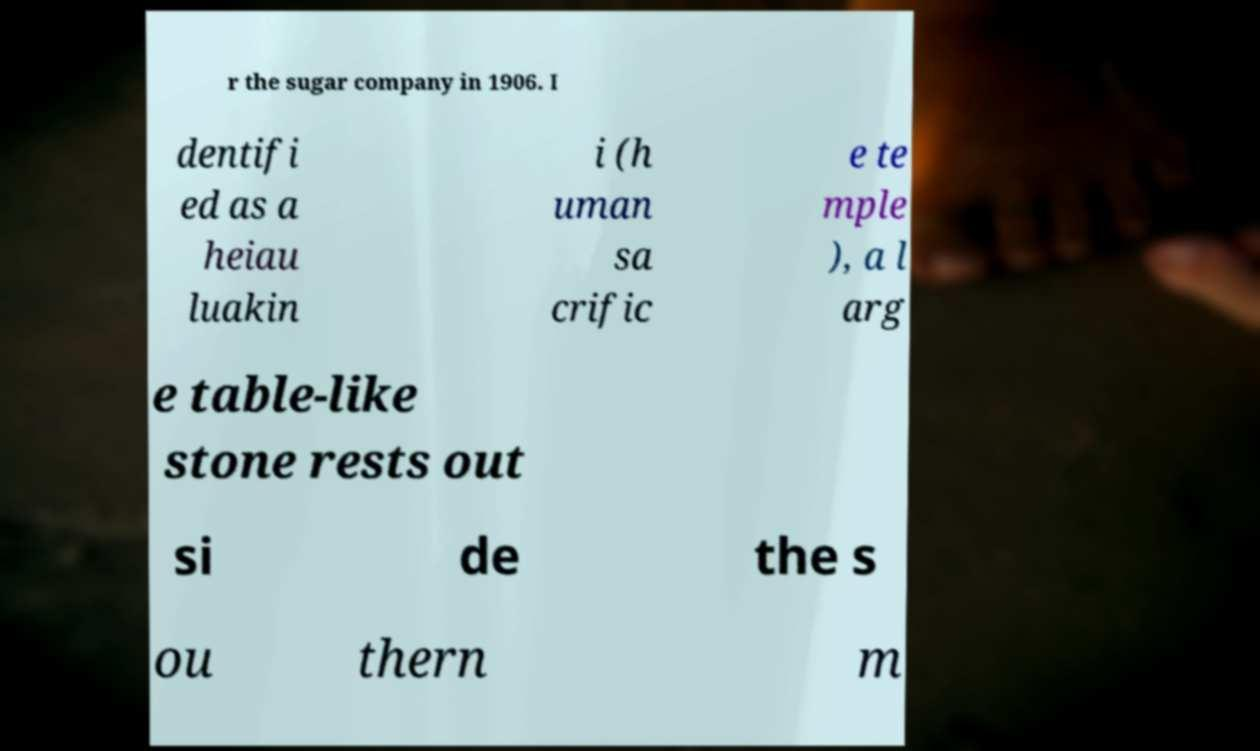For documentation purposes, I need the text within this image transcribed. Could you provide that? r the sugar company in 1906. I dentifi ed as a heiau luakin i (h uman sa crific e te mple ), a l arg e table-like stone rests out si de the s ou thern m 